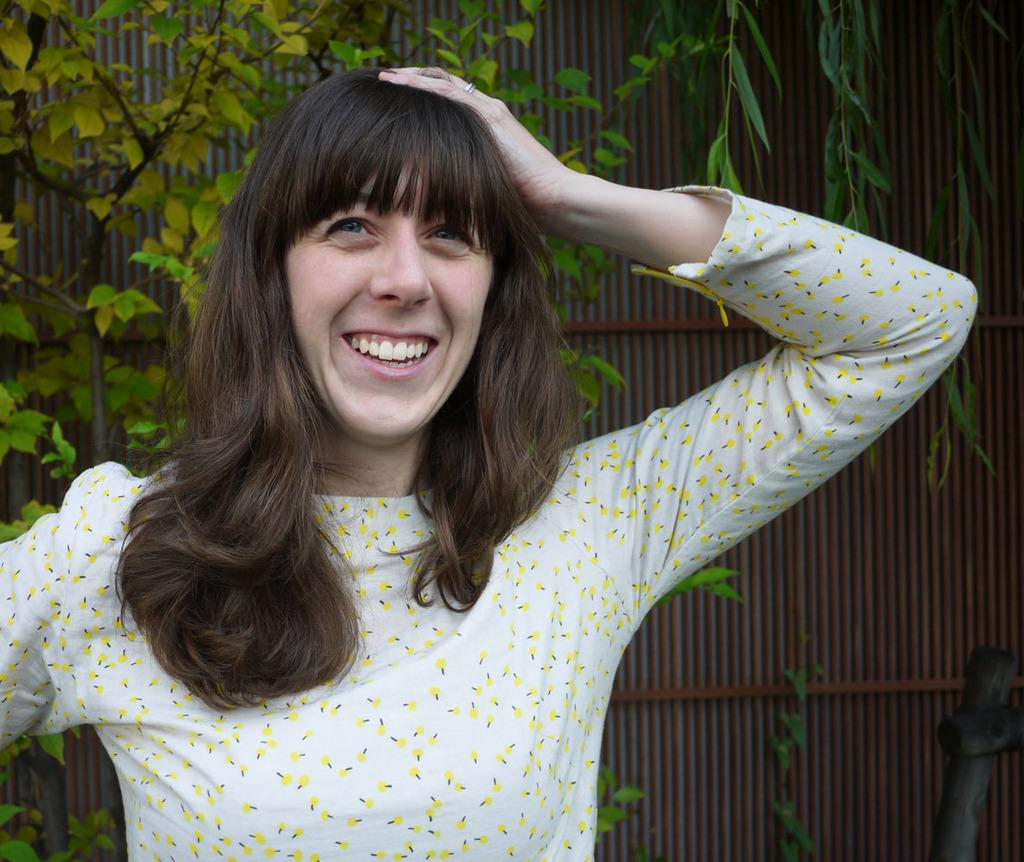What is the main subject of the image? The main subject of the image is a lady. What is the lady doing in the image? The lady is smiling in the image. What can be seen in the background of the image? There is a tree in the background of the image. What type of structure is present in the image? There is a wall in the image. What type of produce is being sold by the lady in the image? There is no produce present in the image, as the lady is not depicted as selling anything. What channel is the lady an expert on in the image? There is no reference to a channel or expertise in the image; it simply shows a lady smiling. 